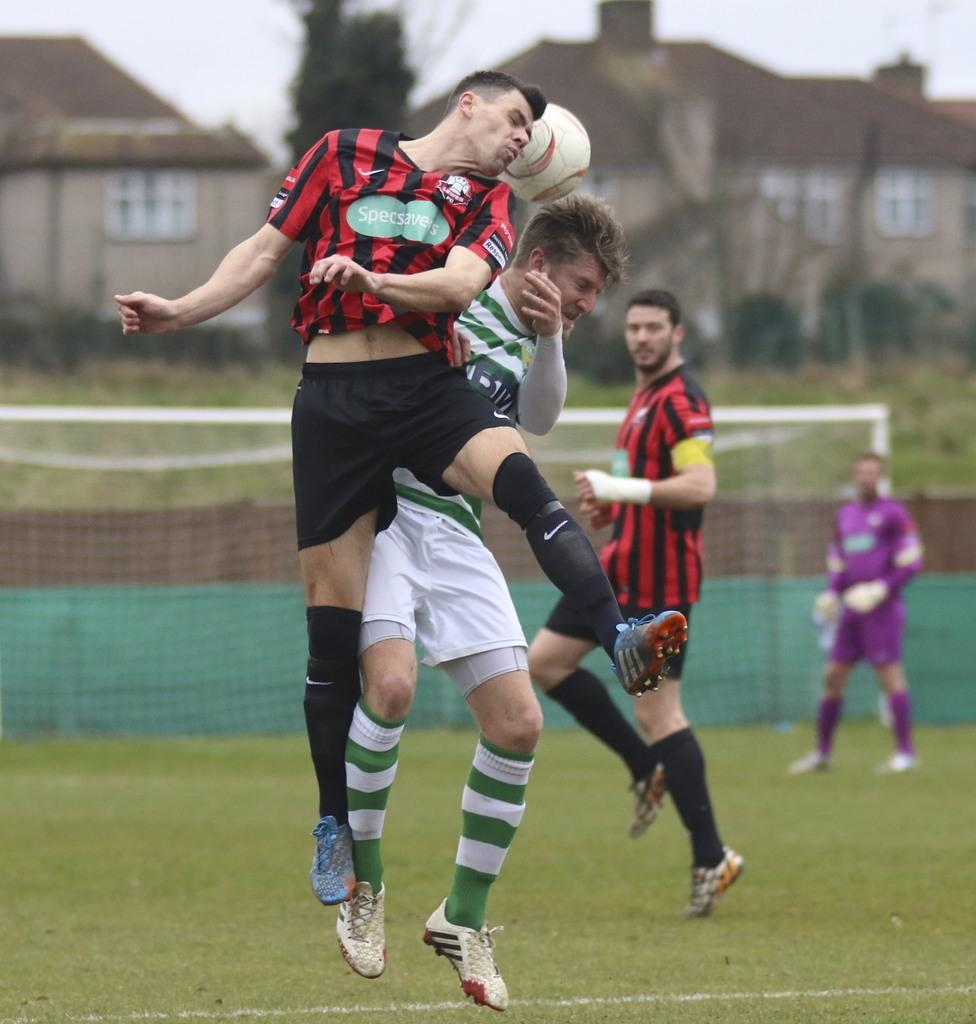How many people are the persons are present in the image? There are four persons in the image. What are the persons doing in the image? The persons are playing with a ball. Can you describe the mesh in the image? Yes, there is a mesh in the image. What can be seen in the background of the image? There are houses and a tree in the background of the image. What is visible at the top of the image? The sky is visible in the image. What type of seed can be seen growing near the tree in the image? There is no seed visible near the tree in the image. What game are the persons playing in the image? The provided facts do not specify the name of the game the persons are playing; they are simply playing with a ball. 